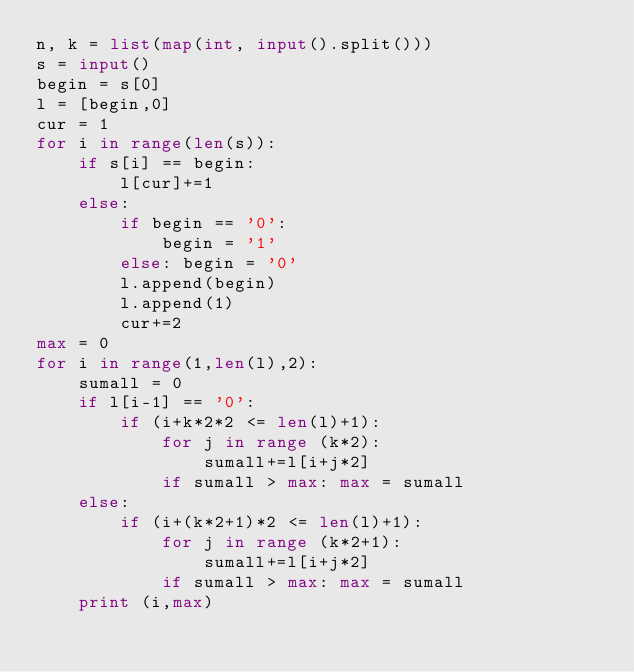Convert code to text. <code><loc_0><loc_0><loc_500><loc_500><_Python_>n, k = list(map(int, input().split()))
s = input()
begin = s[0]
l = [begin,0]
cur = 1
for i in range(len(s)):
    if s[i] == begin:
        l[cur]+=1
    else:
        if begin == '0':
            begin = '1'
        else: begin = '0'
        l.append(begin)
        l.append(1)
        cur+=2
max = 0
for i in range(1,len(l),2):
    sumall = 0
    if l[i-1] == '0':
        if (i+k*2*2 <= len(l)+1):
            for j in range (k*2):
                sumall+=l[i+j*2]
            if sumall > max: max = sumall
    else:
        if (i+(k*2+1)*2 <= len(l)+1):
            for j in range (k*2+1):
                sumall+=l[i+j*2]
            if sumall > max: max = sumall
    print (i,max)
</code> 